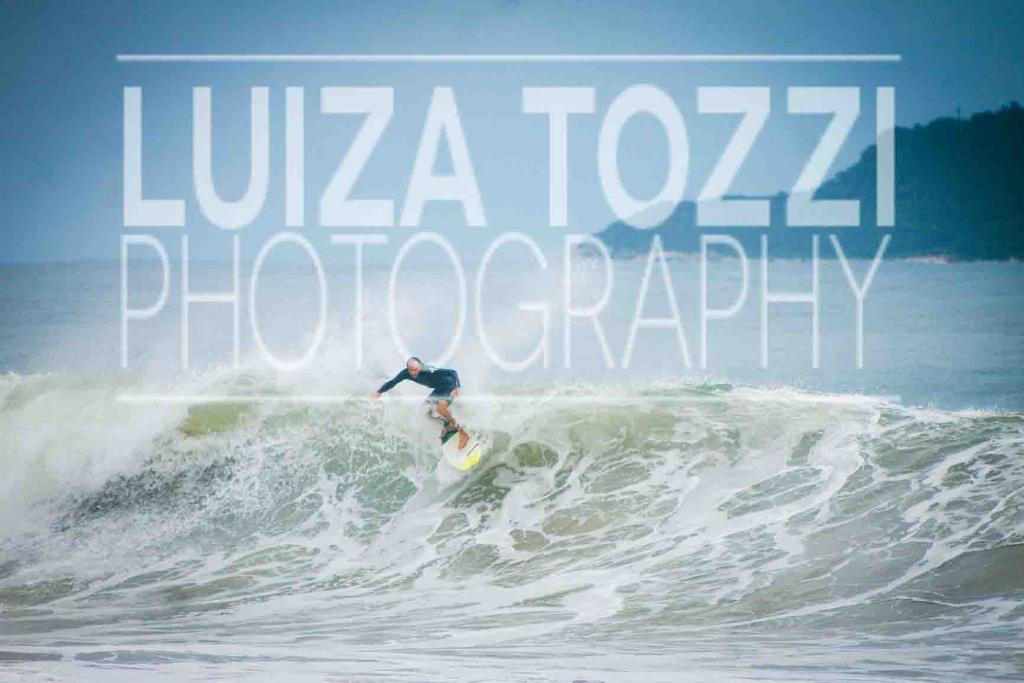Please provide a concise description of this image. In this image we can see a person surfing in a sea, behind him there is a mountain and some text is written on the image. 